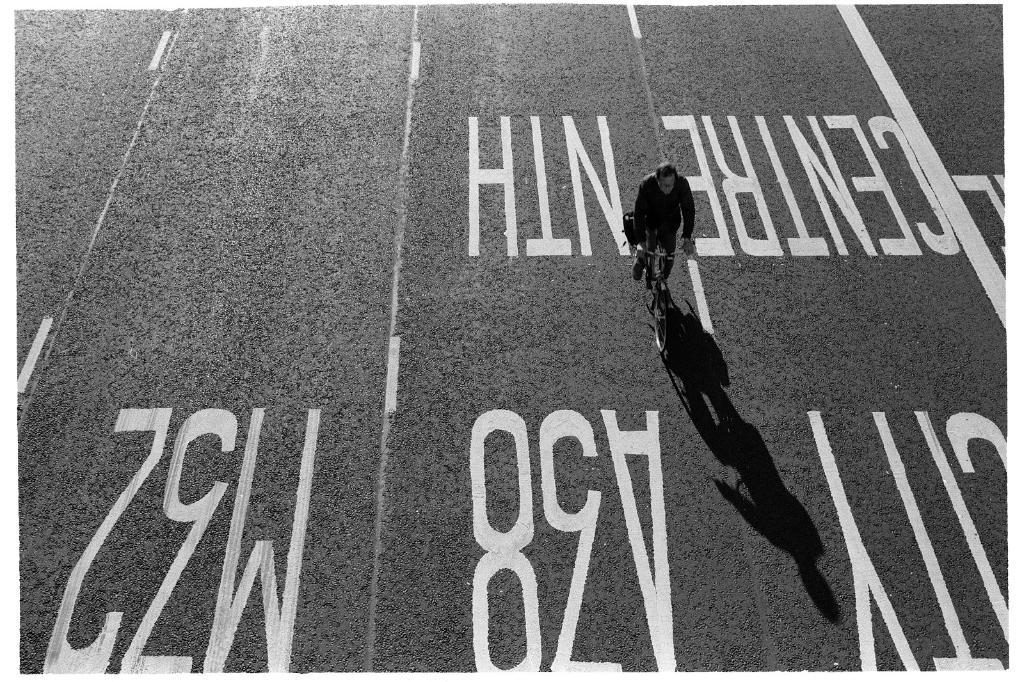What is the sign that the cyclist just rode past?
Keep it short and to the point. Centre nth. 